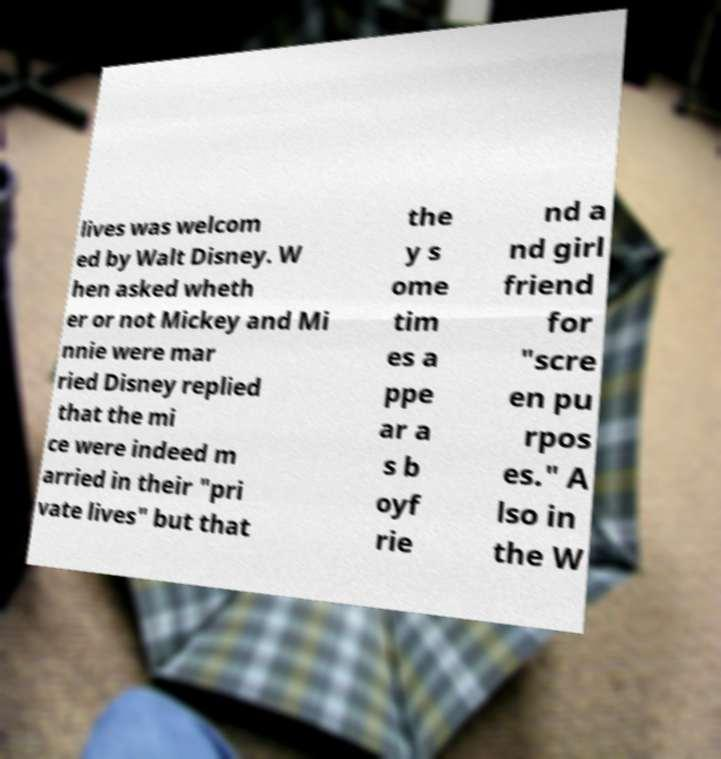Could you extract and type out the text from this image? lives was welcom ed by Walt Disney. W hen asked wheth er or not Mickey and Mi nnie were mar ried Disney replied that the mi ce were indeed m arried in their "pri vate lives" but that the y s ome tim es a ppe ar a s b oyf rie nd a nd girl friend for "scre en pu rpos es." A lso in the W 